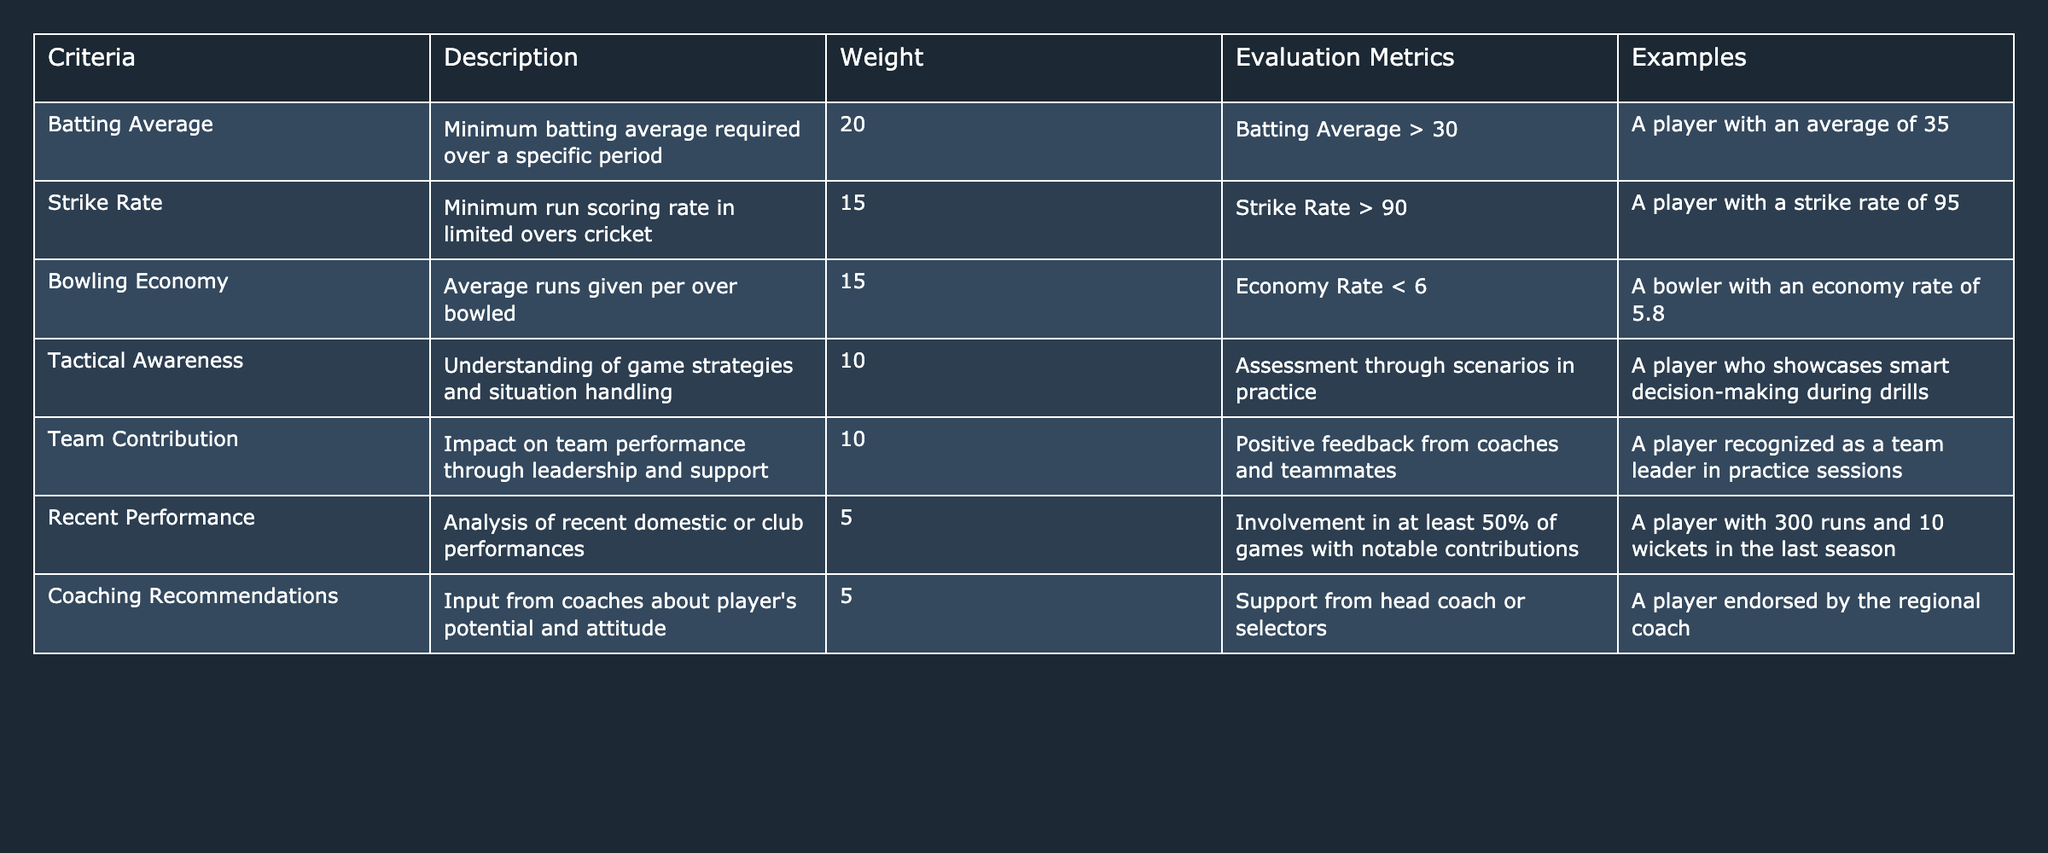What is the weight assigned to Batting Average in the selection criteria? The table lists the criteria, their descriptions, and weights. The weight assigned to Batting Average is 20.
Answer: 20 What is the minimum required Strike Rate according to the evaluation metrics? The table specifies the evaluation metrics related to Strike Rate, which states that it must be greater than 90.
Answer: Greater than 90 Which evaluation metric has the lowest weight? By examining the weights for each evaluation metric, Coaching Recommendations and Recent Performance both have the lowest weight of 5.
Answer: 5 Is Tactical Awareness a criterion for selection? The table indicates that Tactical Awareness is indeed one of the selection criteria.
Answer: Yes What is the total weight of the criteria related to batting? The table includes two batting-related criteria: Batting Average (20) and Strike Rate (15). The sum is 20 + 15 = 35.
Answer: 35 If a player has a Bowling Economy of 5.5, does that meet the evaluation metric? The evaluation metric for Bowling Economy requires an economy rate less than 6. Since 5.5 is less than 6, that requirement is met.
Answer: Yes How many criteria have a weight greater than 10? The criteria with weights greater than 10 are Batting Average (20), Strike Rate (15), and Bowling Economy (15). There are three of them.
Answer: 3 What is the combined weight of the Team Contribution and Recent Performance criteria? The weight for Team Contribution is 10 and for Recent Performance is 5. Adding them gives 10 + 5 = 15.
Answer: 15 Which criterion values are evaluated based on feedback from coaches? The criterion evaluated based on feedback from coaches is Coaching Recommendations, with an emphasis on input about player's potential and attitude.
Answer: Coaching Recommendations If a player has a batting average of 30 and a strike rate of 88, do they meet both evaluation metrics? The player meets the batting average requirement of being greater than 30 but fails to meet the strike rate requirement of being greater than 90. Hence, not both are met.
Answer: No 